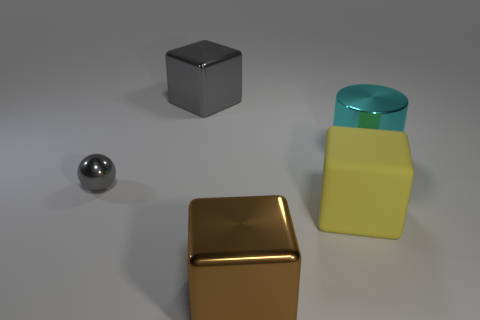Subtract all brown cubes. How many cubes are left? 2 Subtract all yellow blocks. How many blocks are left? 2 Add 2 tiny objects. How many objects exist? 7 Subtract all yellow blocks. Subtract all purple spheres. How many blocks are left? 2 Subtract all gray cylinders. How many gray cubes are left? 1 Subtract all tiny purple matte spheres. Subtract all metallic objects. How many objects are left? 1 Add 4 gray cubes. How many gray cubes are left? 5 Add 1 small gray metal blocks. How many small gray metal blocks exist? 1 Subtract 0 purple blocks. How many objects are left? 5 Subtract all blocks. How many objects are left? 2 